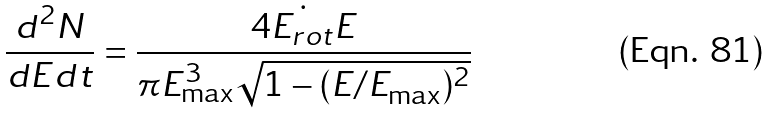Convert formula to latex. <formula><loc_0><loc_0><loc_500><loc_500>\frac { d ^ { 2 } N } { d E d t } = \frac { 4 \dot { E _ { r o t } } E } { \pi E _ { \max } ^ { 3 } \sqrt { 1 - ( E / E _ { \max } ) ^ { 2 } } }</formula> 